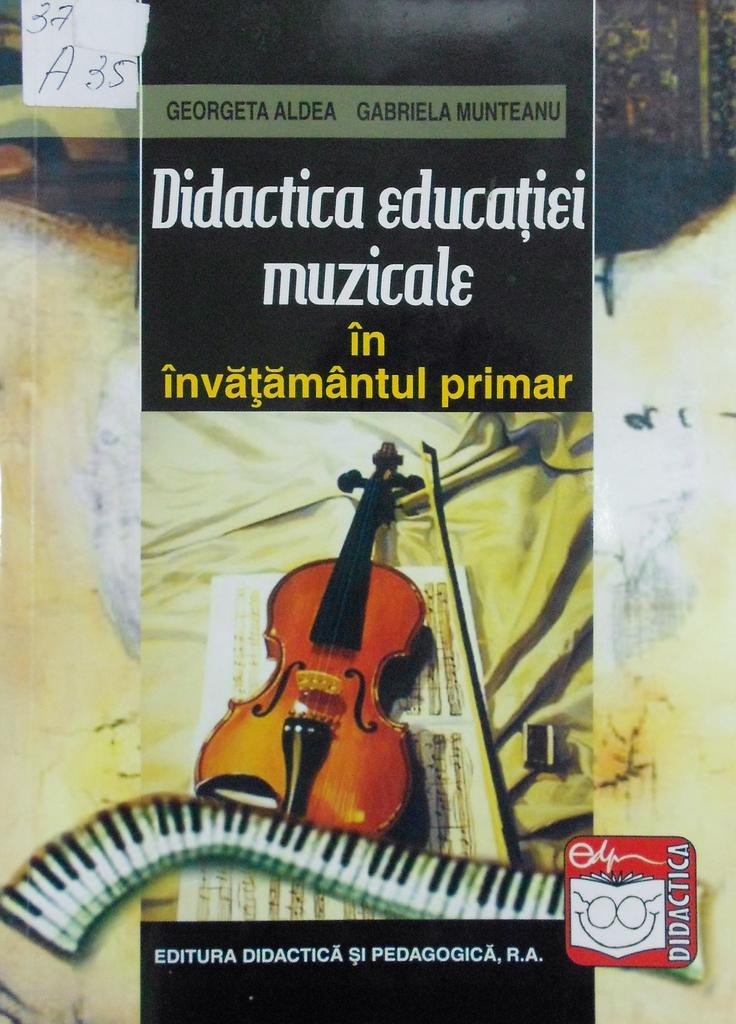What is the main subject of the poster in the image? The poster contains a picture of a guitar. What else can be seen on the poster besides the guitar? There is text on the poster. What year is depicted on the poster? There is no year depicted on the poster; it features a picture of a guitar and text. What emotion is expressed by the guitar on the poster? The guitar is an inanimate object and cannot express emotions like anger. 